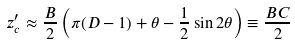<formula> <loc_0><loc_0><loc_500><loc_500>z _ { c } ^ { \prime } \approx \frac { B } { 2 } \left ( \pi ( D - 1 ) + \theta - \frac { 1 } { 2 } \sin 2 \theta \right ) \equiv \frac { B C } { 2 }</formula> 